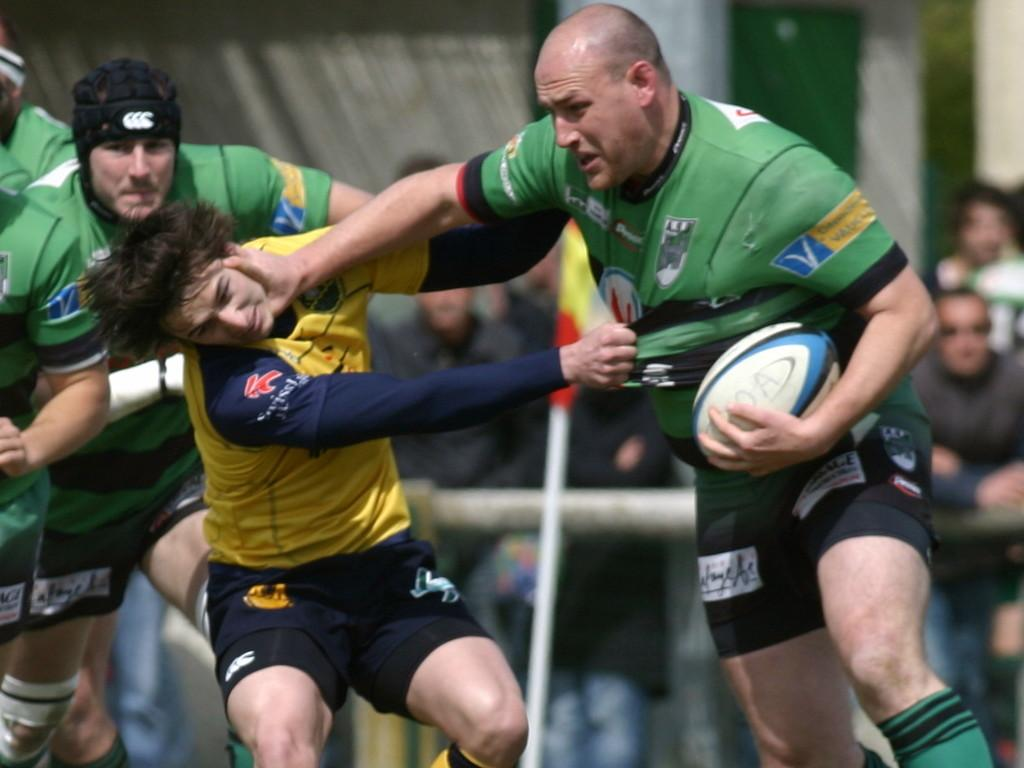What activity are the people in the image engaged in? The people in the image are playing a game. What object is being used in the game? A person is holding a ball in the image. Can you describe the interaction between the two people? Another person is grabbing the t-shirt of the person holding the ball. What type of carpenter tools can be seen in the image? There are no carpenter tools present in the image. Where is the park located in the image? There is no park present in the image. 